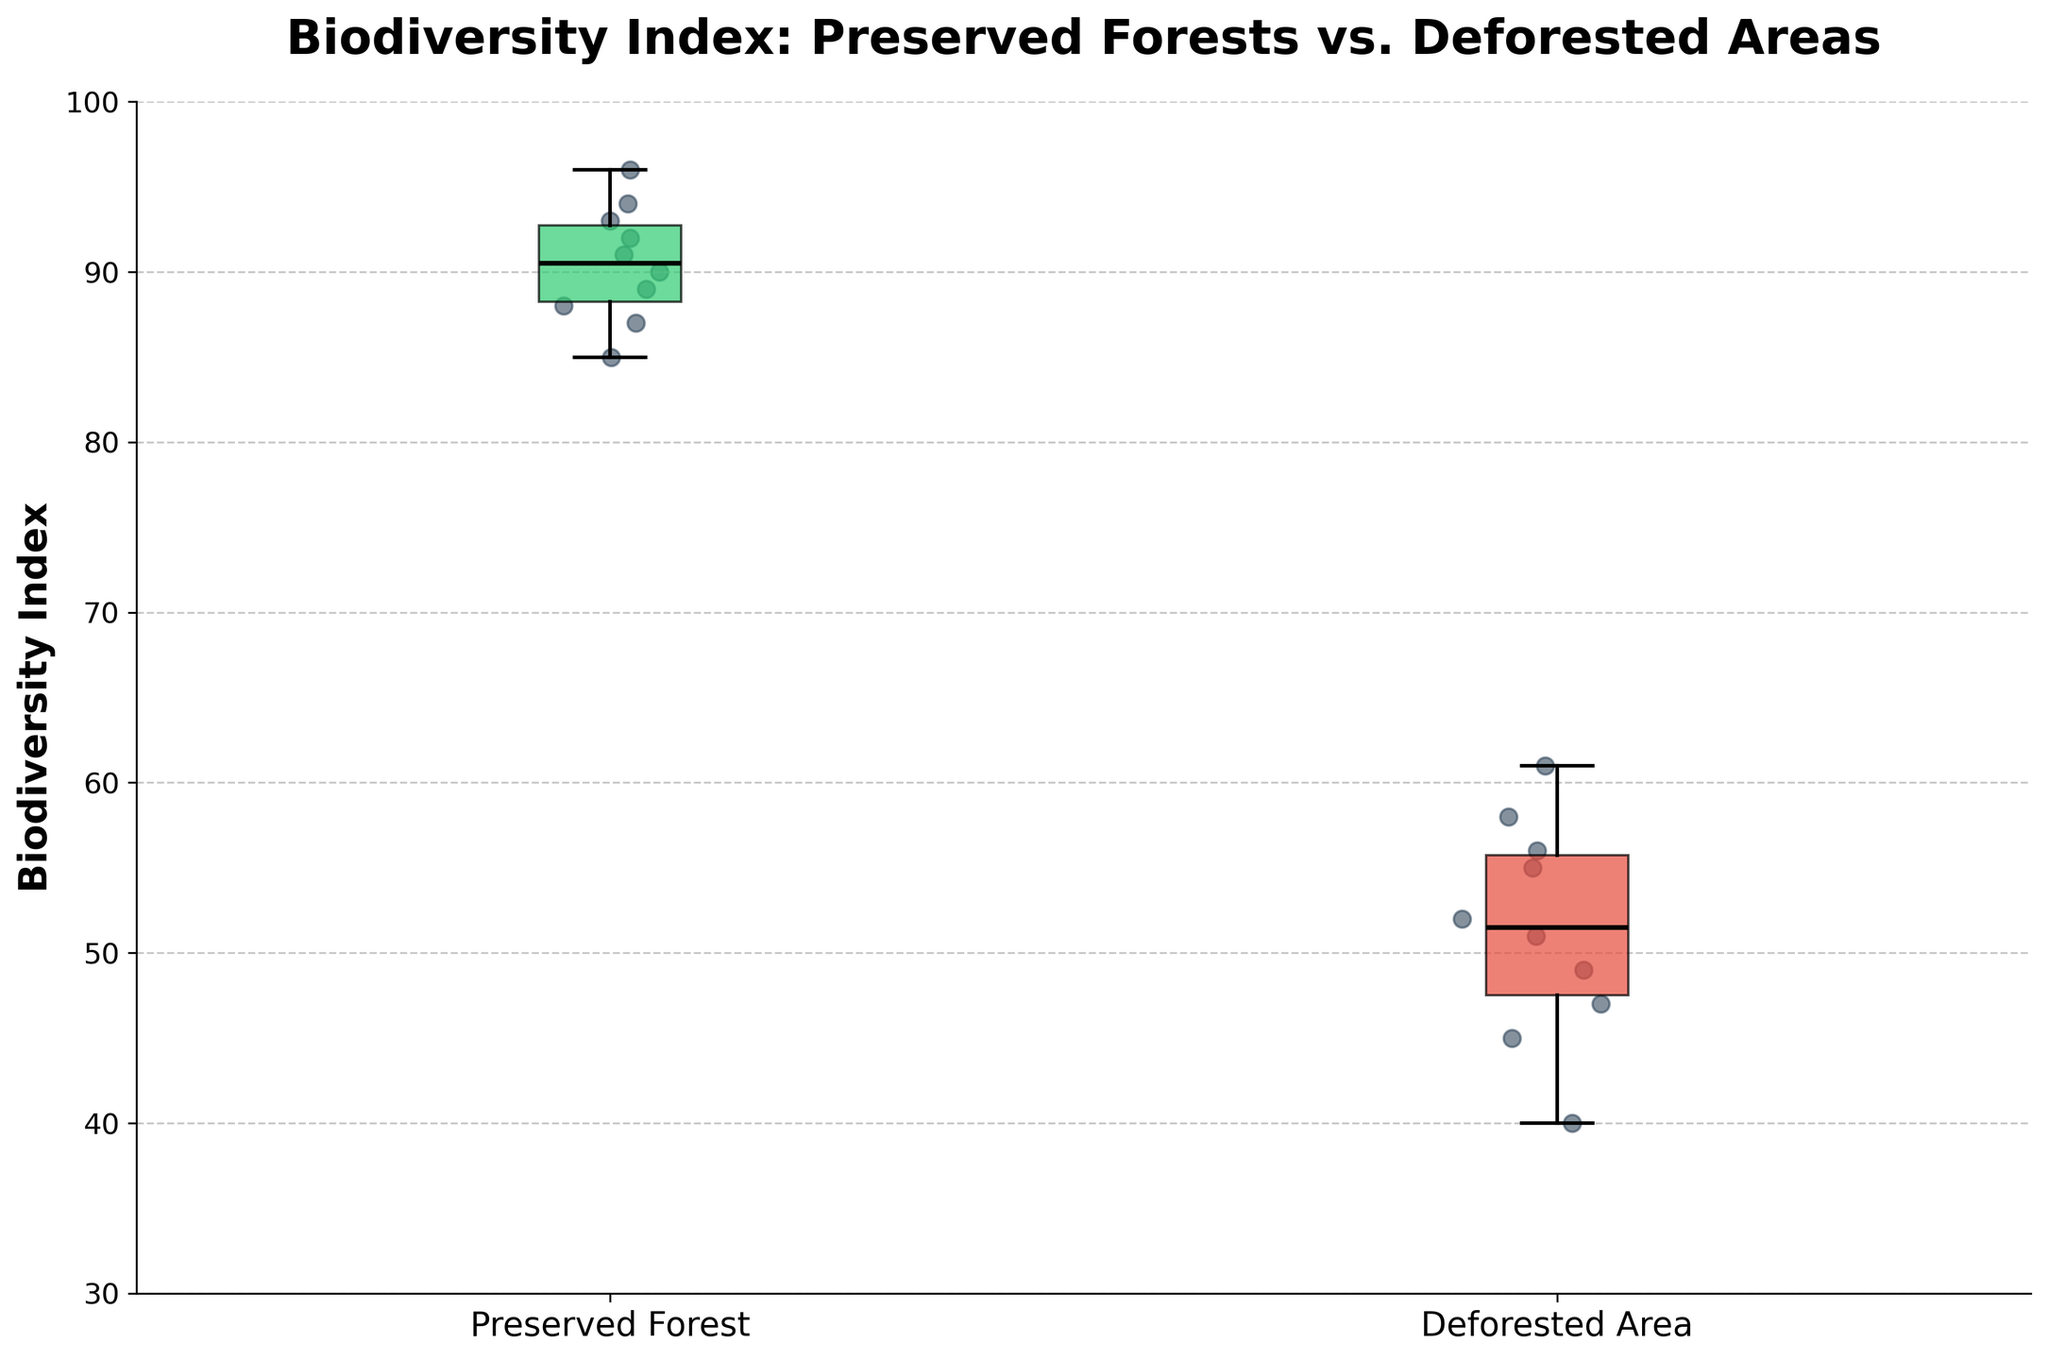What's the title of the figure? The title is displayed at the top of the figure. It summarizes what the figure is about.
Answer: Biodiversity Index: Preserved Forests vs. Deforested Areas What does the y-axis represent? The label on the y-axis indicates it represents the Biodiversity Index.
Answer: Biodiversity Index Which group exhibits higher values overall? By observing the position of the boxes (the range of the data), we can see which group has generally higher values.
Answer: Preserved Forests What is the median Biodiversity Index for Preserved Forests? The median is marked by the line inside the box. In the box plot for Preserved Forests, the line is around 90.
Answer: 90 What is the median Biodiversity Index for Deforested Areas? The median is the line inside the box for Deforested Areas, which is around 52.
Answer: 52 What color represents the Preserved Forests group? The boxes have different colors to distinguish the groups. The lighter green-shaded box represents the Preserved Forests.
Answer: Green In which group is the spread of the Biodiversity Index wider? The spread is indicated by the length of the box and the whiskers. The group with a larger spread in the vertical direction has wider spread values.
Answer: Preserved Forests Which region in Preserved Forests shows the lowest Biodiversity Index value? Scatter points represent individual observations. The lowest point in the Preserved Forests group is around 85, which corresponds to Sherwood Forest.
Answer: Sherwood Forest Which group has outliers, if any? Outliers are typically shown as individual points beyond the whiskers. In this figure, no such points indicate outliers for either group.
Answer: None What is the range of Biodiversity Index for the Deforested Areas? The range is the difference between the maximum and minimum values in the Deforested Areas box plot. Maximum is around 61, and minimum is around 40, so 61 - 40 = 21.
Answer: 21 